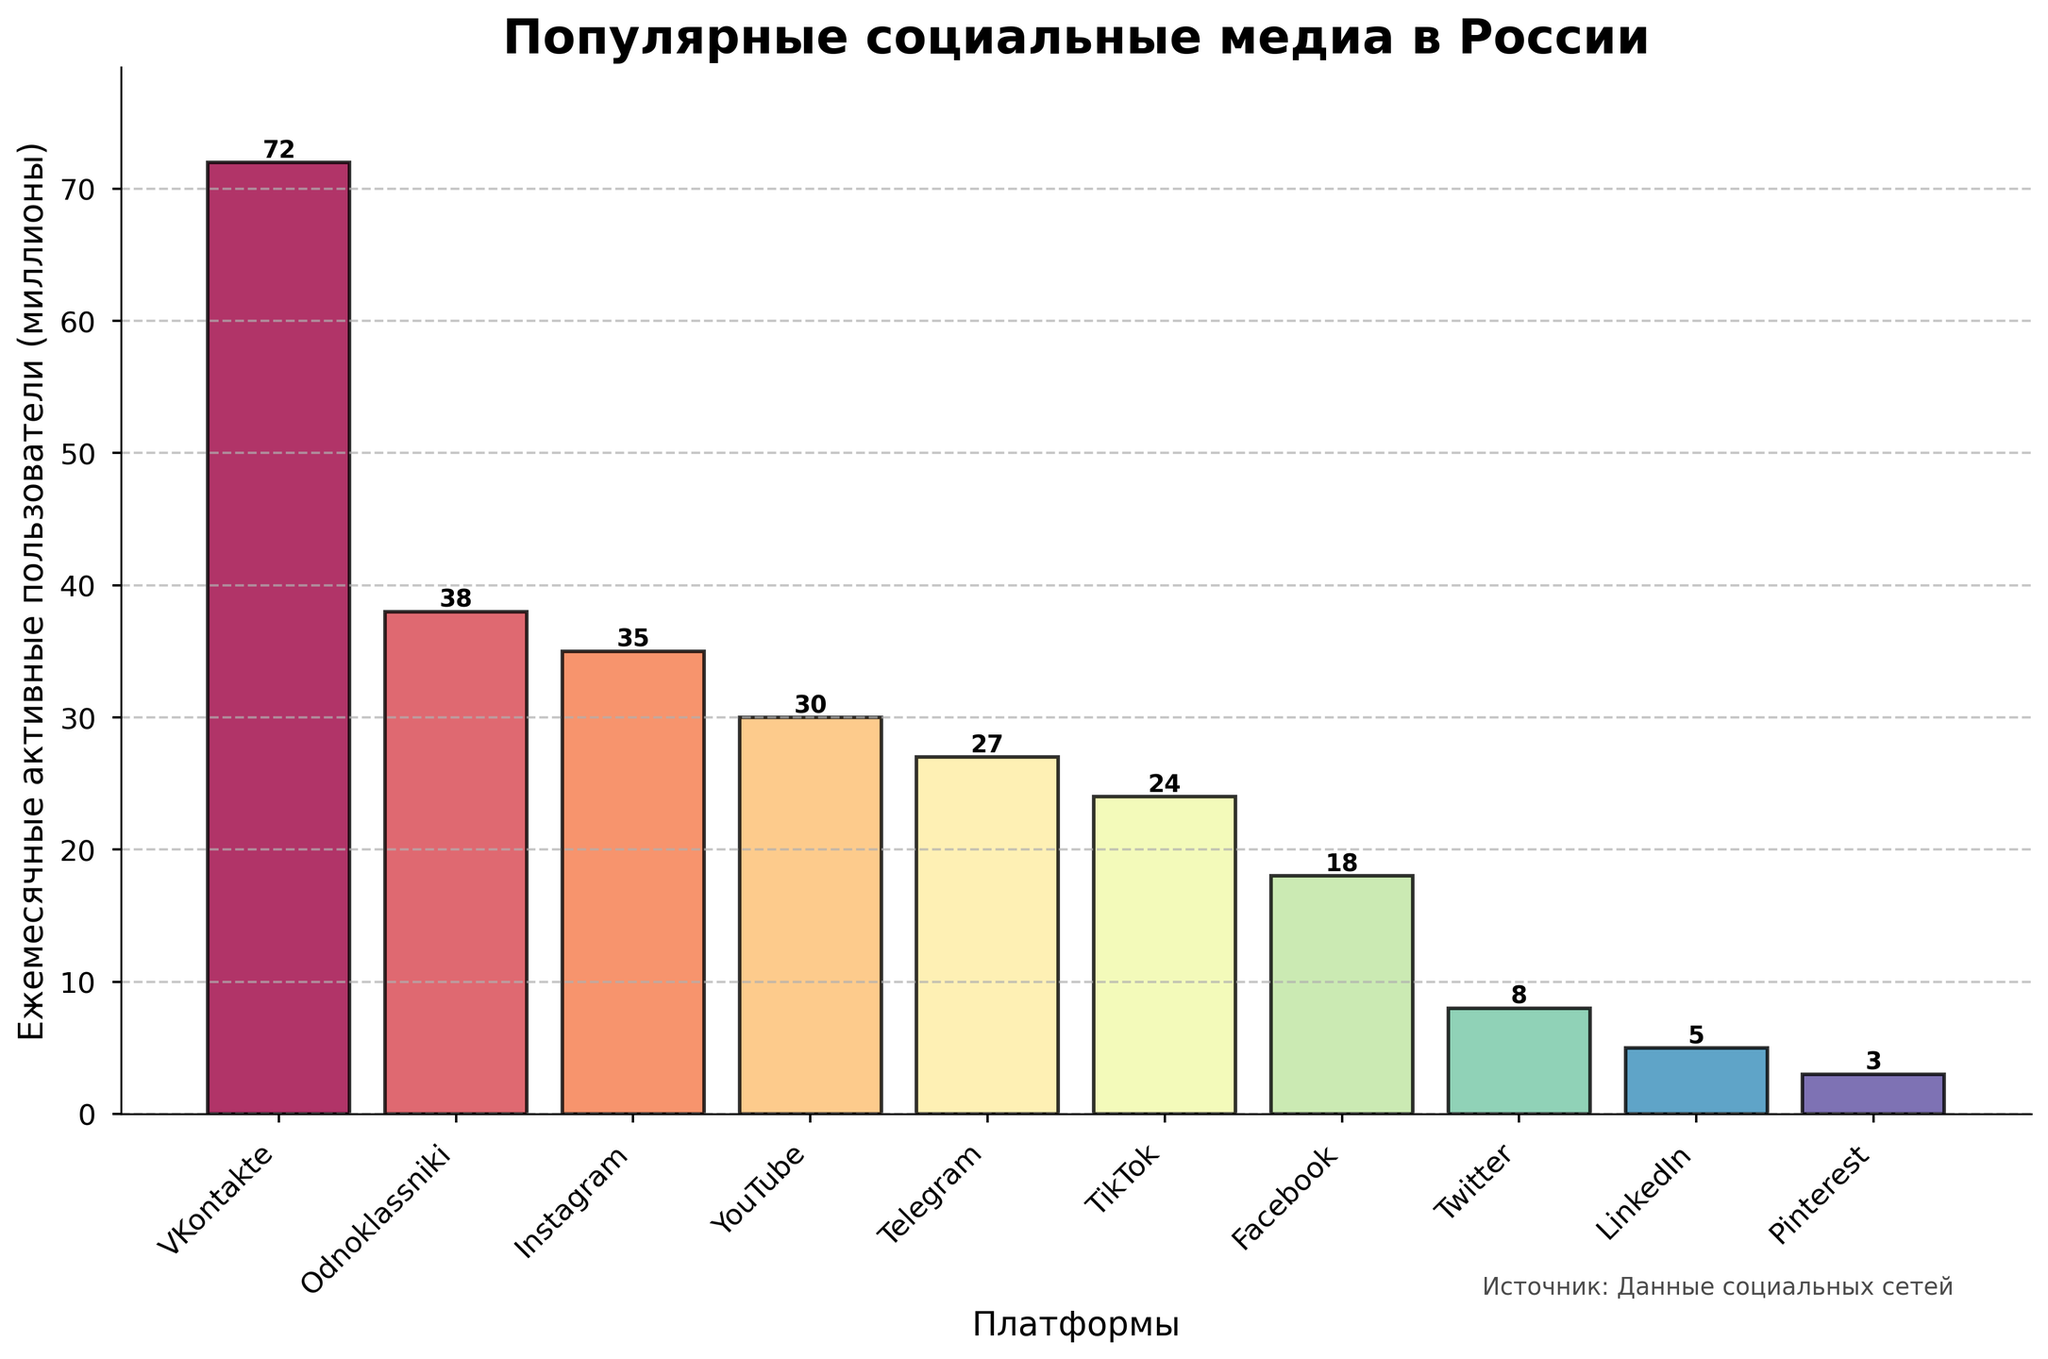Which social media platform has the highest number of monthly active users? The platform with the tallest bar represents the social media platform with the highest number of monthly active users, which is VKontakte with 72 million users.
Answer: VKontakte How many more monthly active users does VKontakte have compared to Odnoklassniki? VKontakte has 72 million users, and Odnoklassniki has 38 million users. The difference is 72 - 38 = 34 million users.
Answer: 34 million What is the total number of monthly active users for Instagram and YouTube combined? Instagram has 35 million users, and YouTube has 30 million users. Their combined total is 35 + 30 = 65 million users.
Answer: 65 million Which platform has fewer monthly active users, Twitter or LinkedIn? By comparing the heights of the bars, LinkedIn has 5 million monthly active users, whereas Twitter has 8 million. LinkedIn has fewer users.
Answer: LinkedIn What is the average number of monthly active users for Telegram, TikTok, and Facebook? Telegram has 27 million, TikTok has 24 million, and Facebook has 18 million monthly active users. The sum is 27 + 24 + 18 = 69 million, and the average is 69 / 3 = 23 million.
Answer: 23 million How many platforms have monthly active users between 20 million and 40 million? Odnoklassniki (38 million), Instagram (35 million), YouTube (30 million), Telegram (27 million), and TikTok (24 million) fall within this range. There are 5 platforms in total.
Answer: 5 Which platform has nearly one-third the number of monthly active users as VKontakte? VKontakte has 72 million users, so one-third of that is 72 / 3 = 24 million. TikTok has 24 million users, which is nearly one-third the number of VKontakte's users.
Answer: TikTok What is the difference in monthly active users between the least popular and the most popular platforms? The least popular platform is Pinterest with 3 million users, and the most popular is VKontakte with 72 million users. The difference is 72 - 3 = 69 million.
Answer: 69 million Which platform's bar is exactly halfway in height between Pinterest's and Instagram's bars? Pinterest has 3 million users, and Instagram has 35 million. The halfway point is (3 + 35) / 2 = 19 million. Facebook, with 18 million users, has a bar closest to this midpoint.
Answer: Facebook 